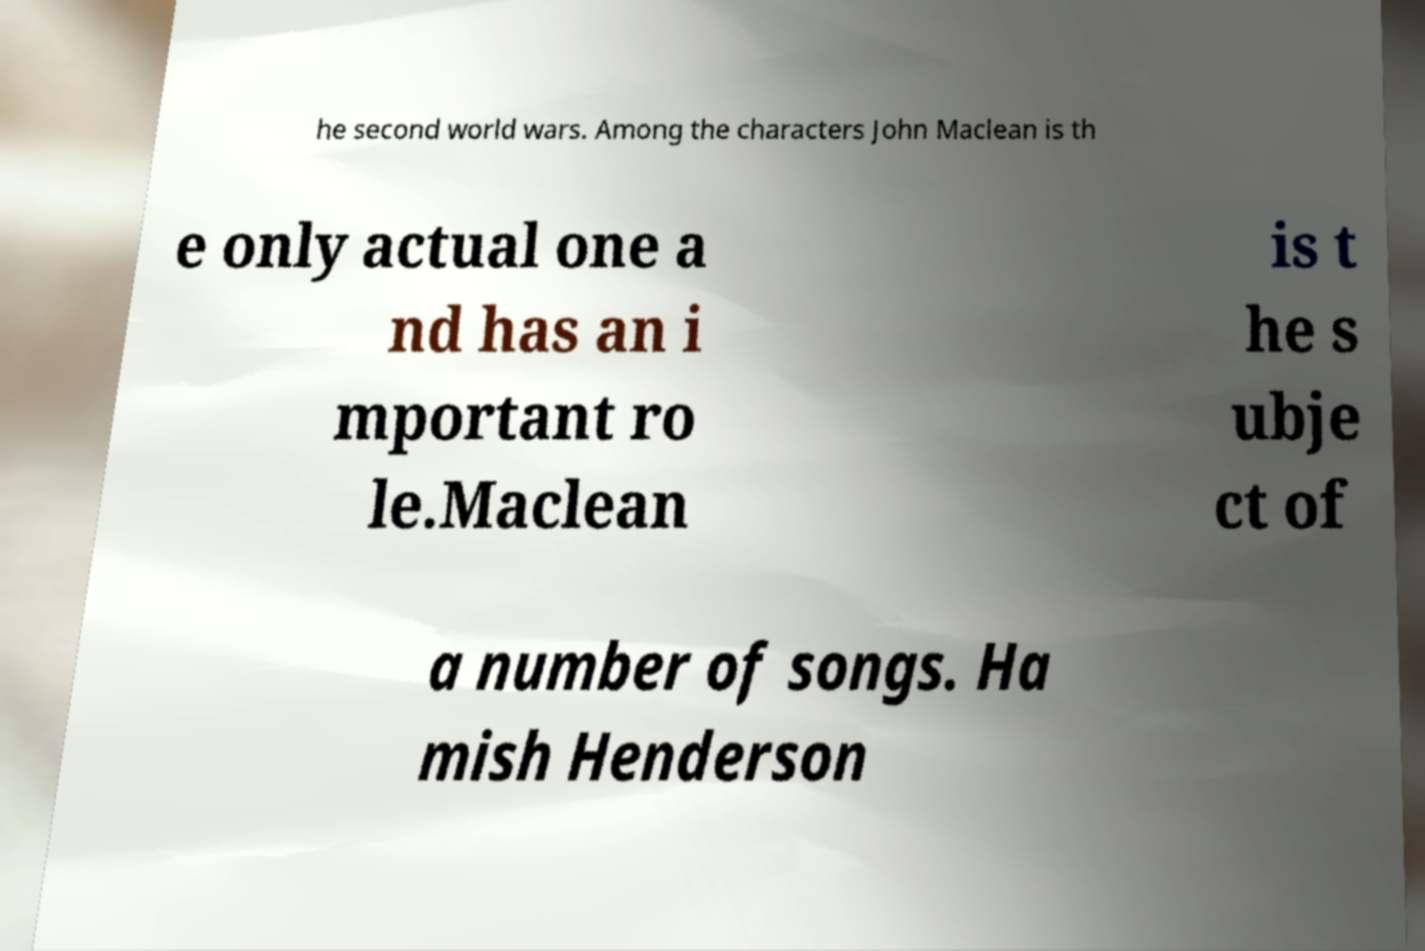Could you extract and type out the text from this image? he second world wars. Among the characters John Maclean is th e only actual one a nd has an i mportant ro le.Maclean is t he s ubje ct of a number of songs. Ha mish Henderson 